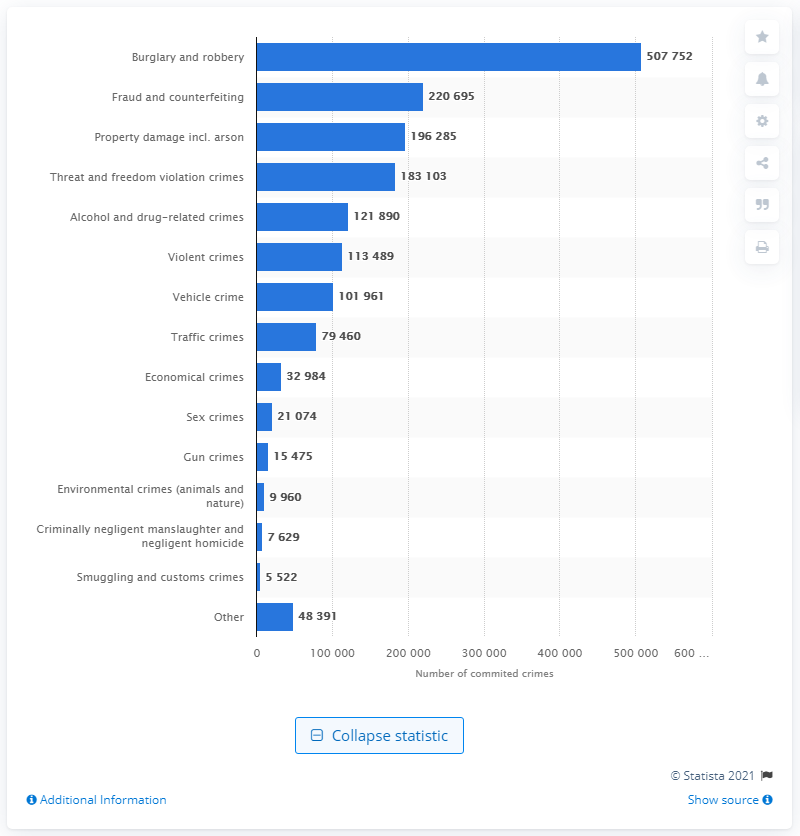List a handful of essential elements in this visual. The second most common crime type in Sweden in 2016 was fraud and counterfeiting. 